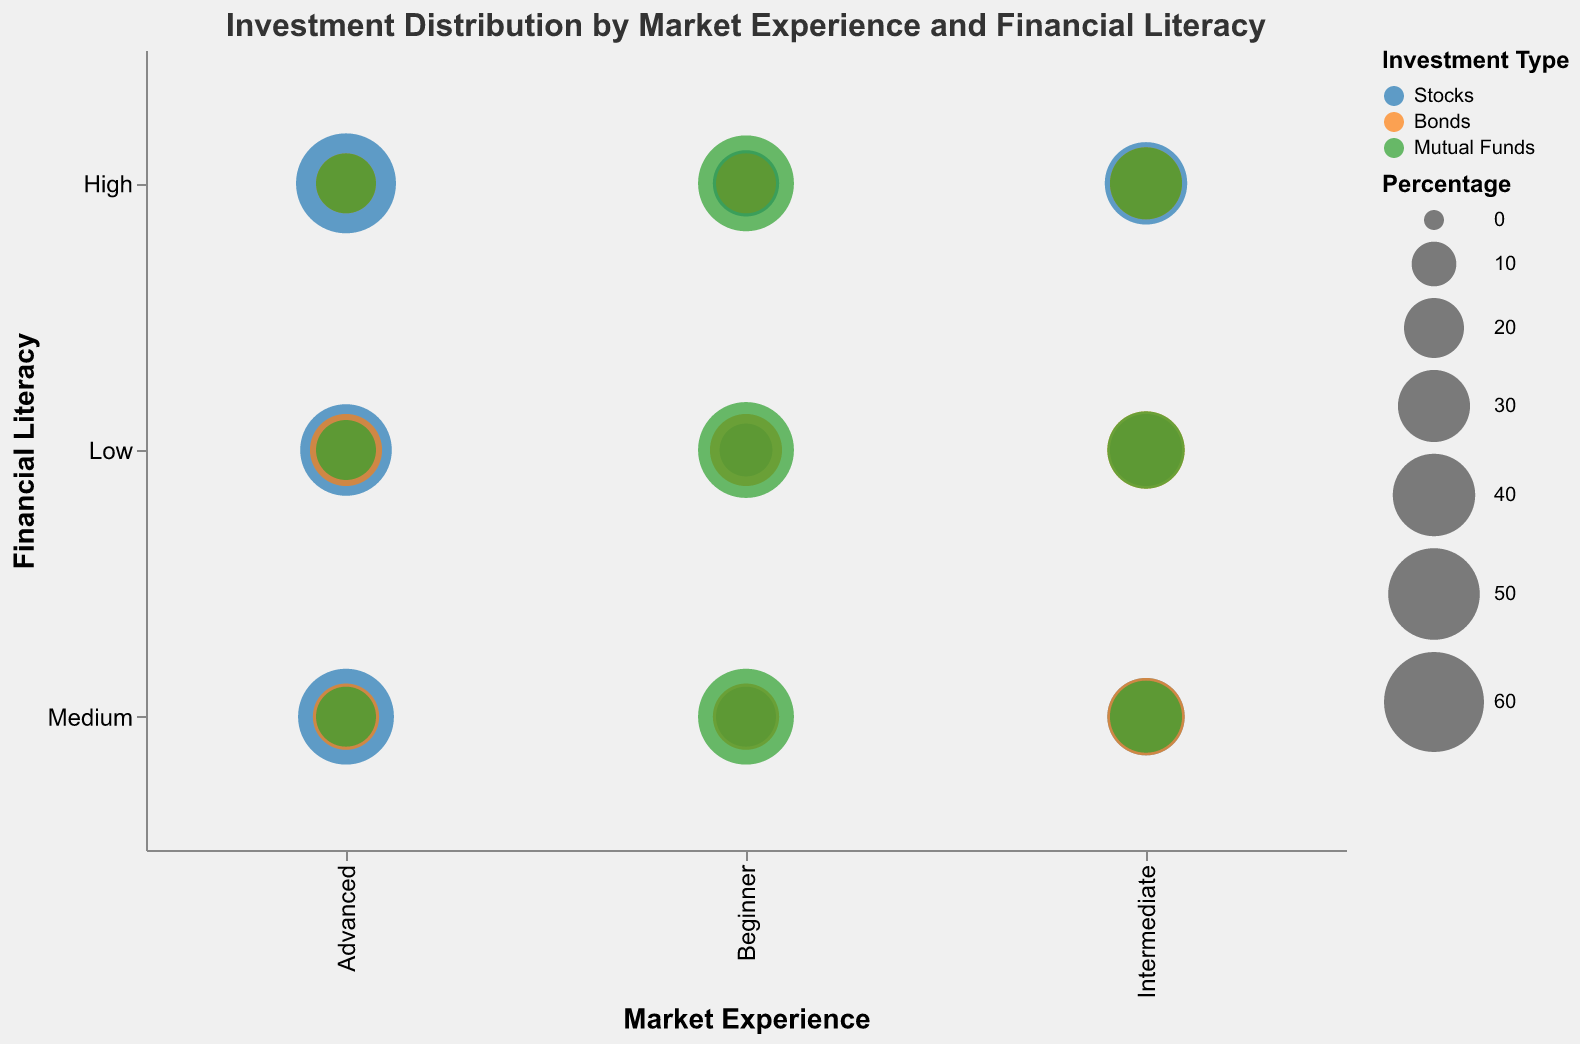What's the title of the figure? The title of the chart is prominently displayed at the top of the figure. It states the overall topic of the visualized data.
Answer: Investment Distribution by Market Experience and Financial Literacy What color represents "Stocks" in the bubble chart? The color representing each investment type is indicated by the chart legend. "Stocks" is associated with a particular color.
Answer: Blue Which investment type has the smallest percentage for "Advanced" investors with "Low" financial literacy? By locating the "Advanced" experience level on the x-axis and "Low" financial literacy level on the y-axis, we observe the corresponding bubble sizes for "Stocks," "Bonds," and "Mutual Funds."
Answer: Mutual Funds What is the common percentage of "Mutual Funds" across all experience levels for "High" financial literacy? Examine the sizes of the bubbles corresponding to "Mutual Funds" at each experience level on the x-axis where the financial literacy is "High." All sizes should be compared to deduce a common figure.
Answer: 55% How does the percentage of "Stocks" for "Intermediate" investors with "Medium" financial literacy compare to "Advanced" investors with "Low" financial literacy? Look at the respective bubbles for "Stocks" intersecting the "Intermediate-Medium" and "Advanced-Low" coordinates. Compare their sizes.
Answer: 35% vs 50% Which investment type dominates for "Beginner" investors across all financial literacy levels? Observe the sizes of bubbles at the "Beginner" level for "Low," "Medium," and "High" financial literacy. Identify the investment type with the largest bubble consistently.
Answer: Mutual Funds What's the sum percentage of "Bonds" for "Intermediate" investors with "High" financial literacy and "Beginner" investors with "Low" financial literacy? Find the "Bonds" bubble percentages at "Intermediate-High" and "Beginner-Low" positions. Sum these two values.
Answer: 50% How does the distribution of investment types change from "Intermediate" to "Advanced" investors with "Medium" financial literacy? Compare the size of each bubble for "Stocks," "Bonds," and "Mutual Funds" between "Intermediate-Medium" and "Advanced-Medium" coordinates.
Answer: Stocks and Bonds increase, Mutual Funds decrease What percentage of "Stocks" is invested by "Advanced" investors with "High" financial literacy? Locate the bubble for "Stocks" at the intersection of "Advanced" and "High." Read off the percentage from the size or value indicated.
Answer: 60% Which financial literacy level sees a shift from "Mutual Funds" dominance to "Stocks" dominance among "Intermediate" investors? Examine the investment type bubbles across "Low," "Medium," and "High" financial literacy levels within "Intermediate" market experience. Identify where "Stocks" overtakes "Mutual Funds" in percentage.
Answer: High 